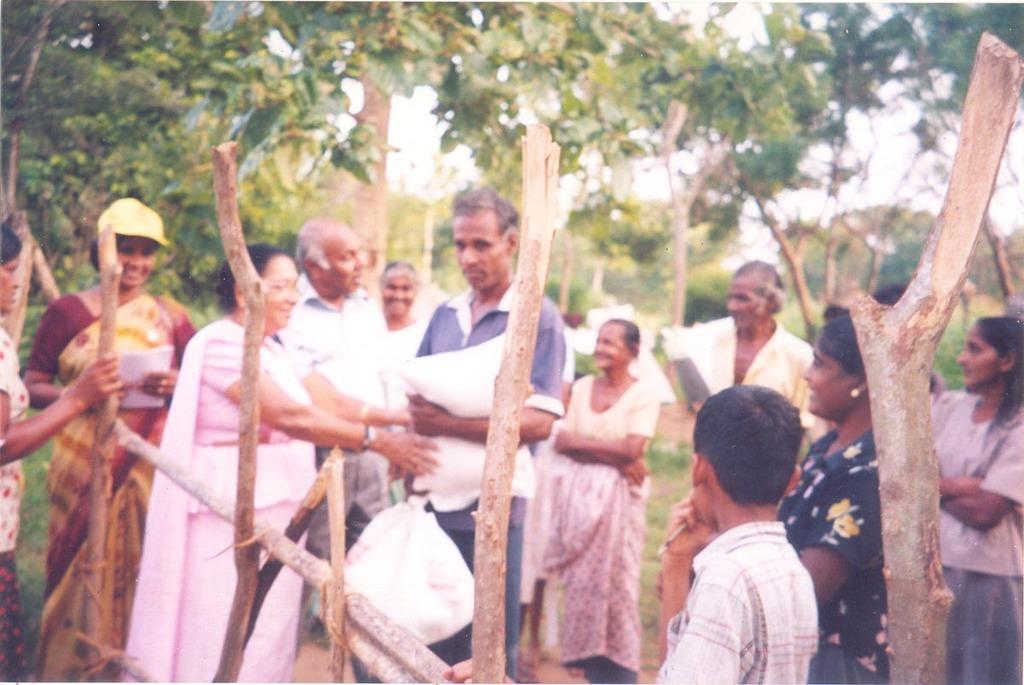Describe this image in one or two sentences. In the middle a man is standing , he wore a t-shirt beside him, there is a woman is also standing. She wore a pink color dress, few other people are also standing at here, in the long back side there are trees. 